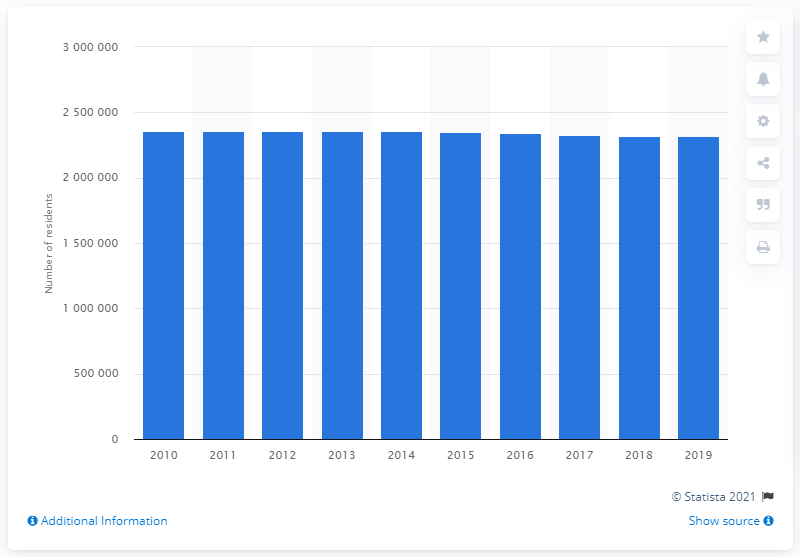Give some essential details in this illustration. In 2019, it is estimated that approximately 2,340,222 individuals resided within the Pittsburgh metropolitan area. 